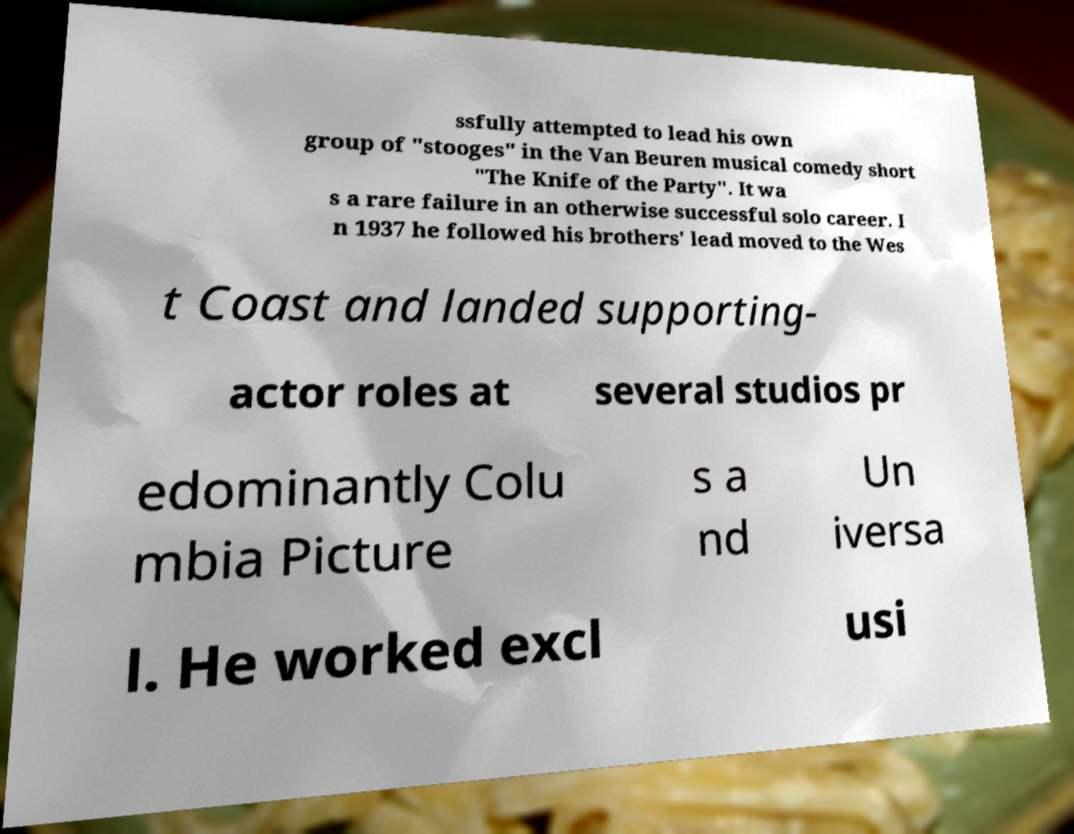Please identify and transcribe the text found in this image. ssfully attempted to lead his own group of "stooges" in the Van Beuren musical comedy short "The Knife of the Party". It wa s a rare failure in an otherwise successful solo career. I n 1937 he followed his brothers' lead moved to the Wes t Coast and landed supporting- actor roles at several studios pr edominantly Colu mbia Picture s a nd Un iversa l. He worked excl usi 